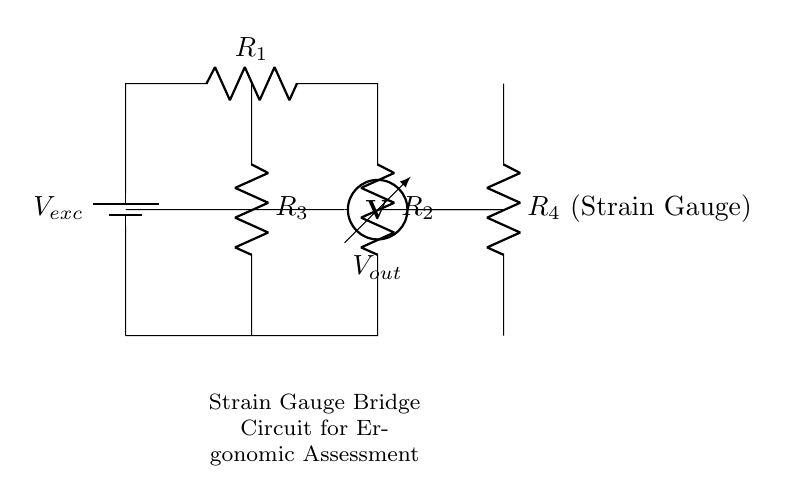What type of circuit is represented here? This configuration is known as a strain gauge bridge circuit, commonly used to measure small changes in resistance due to deformation. The arrangement involves resistors in a bridge formation, allowing precise measurement of voltage changes related to strain.
Answer: strain gauge bridge How many resistors are in this circuit? The circuit contains four resistors, labeled R1, R2, R3, and R4. Each resistor plays a role in the balance of the bridge and influences the output voltage based on the strain measured.
Answer: four What is the output measured across in this circuit? The output voltage, denoted as Vout, is measured across the midpoints connecting two pairs of resistors (between R3 and R4). This voltage correlates with the strain detected by the strain gauge.
Answer: Vout What component is represented by R4? R4 is labeled as the strain gauge in this circuit. Strain gauges are specialized resistors that change their resistance in response to mechanical deformation, making them essential for measuring strain in applications like ergonomic assessments.
Answer: Strain Gauge Explain how the bridge is balanced? The bridge is balanced when the voltage across the output (Vout) is zero, meaning the resistances in two paths are equal. This occurs when the ratio of R1/R2 equals R3/R4. Adjustments can be made by changing the values of the resistors until this balance condition is met, which indicates no strain is present.
Answer: When Vout is zero What role does Vexc play in the circuit? Vexc serves as the excitation voltage providing the necessary power to the circuit. It induces the flow of current through the resistors, allowing for the detection of varying voltages at the output due to changes in resistance from the strain gauge.
Answer: Excitation voltage What is the purpose of this strain gauge bridge circuit? The purpose is to assess ergonomic conditions by measuring the strain on office furniture, helping in evaluating its performance and comfort through the detection of stress or deformation under load.
Answer: Ergonomic assessment 